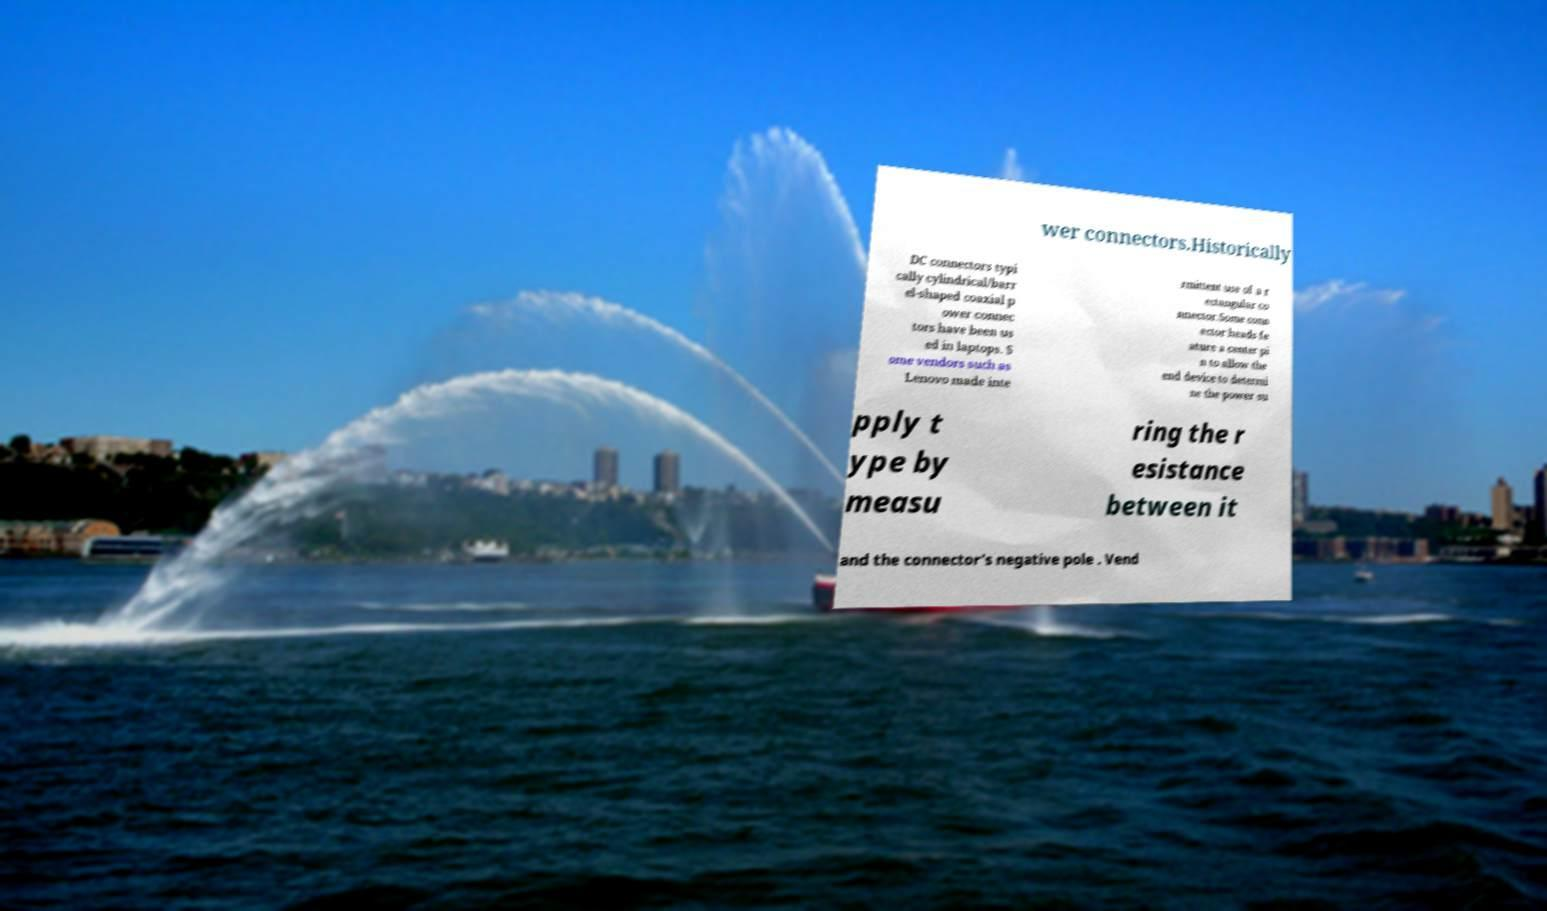What messages or text are displayed in this image? I need them in a readable, typed format. wer connectors.Historically DC connectors typi cally cylindrical/barr el-shaped coaxial p ower connec tors have been us ed in laptops. S ome vendors such as Lenovo made inte rmittent use of a r ectangular co nnector.Some conn ector heads fe ature a center pi n to allow the end device to determi ne the power su pply t ype by measu ring the r esistance between it and the connector's negative pole . Vend 